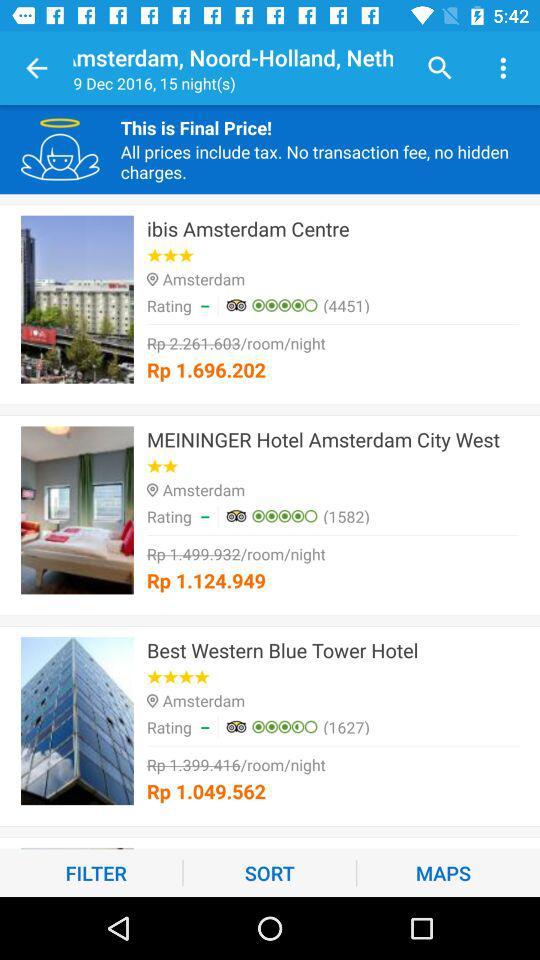How many hotels are there?
Answer the question using a single word or phrase. 3 